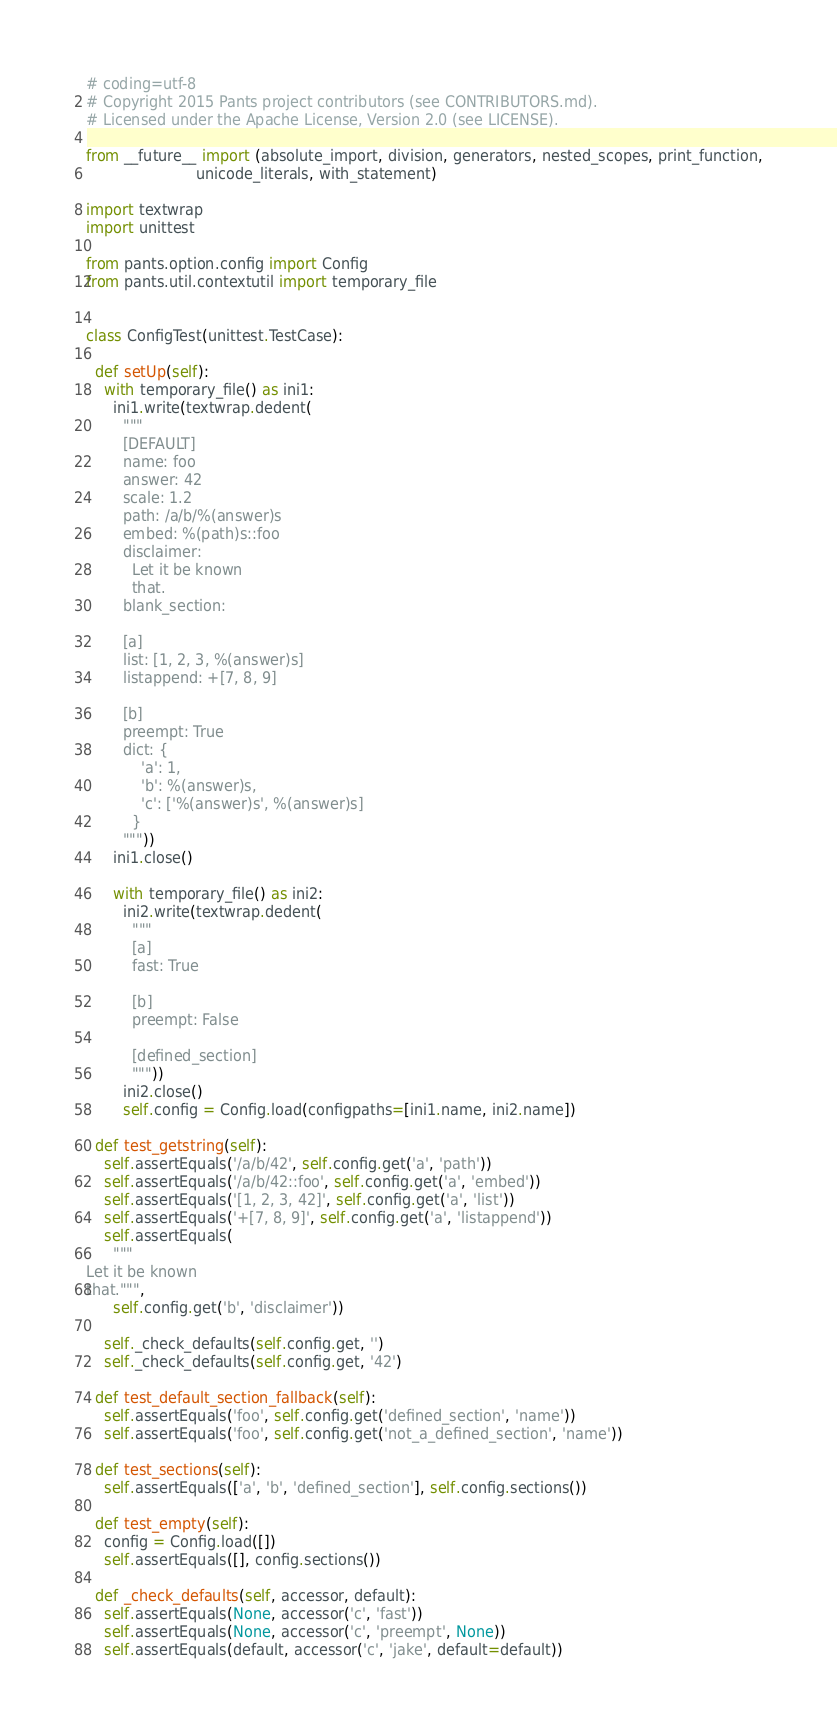<code> <loc_0><loc_0><loc_500><loc_500><_Python_># coding=utf-8
# Copyright 2015 Pants project contributors (see CONTRIBUTORS.md).
# Licensed under the Apache License, Version 2.0 (see LICENSE).

from __future__ import (absolute_import, division, generators, nested_scopes, print_function,
                        unicode_literals, with_statement)

import textwrap
import unittest

from pants.option.config import Config
from pants.util.contextutil import temporary_file


class ConfigTest(unittest.TestCase):

  def setUp(self):
    with temporary_file() as ini1:
      ini1.write(textwrap.dedent(
        """
        [DEFAULT]
        name: foo
        answer: 42
        scale: 1.2
        path: /a/b/%(answer)s
        embed: %(path)s::foo
        disclaimer:
          Let it be known
          that.
        blank_section:

        [a]
        list: [1, 2, 3, %(answer)s]
        listappend: +[7, 8, 9]

        [b]
        preempt: True
        dict: {
            'a': 1,
            'b': %(answer)s,
            'c': ['%(answer)s', %(answer)s]
          }
        """))
      ini1.close()

      with temporary_file() as ini2:
        ini2.write(textwrap.dedent(
          """
          [a]
          fast: True

          [b]
          preempt: False

          [defined_section]
          """))
        ini2.close()
        self.config = Config.load(configpaths=[ini1.name, ini2.name])

  def test_getstring(self):
    self.assertEquals('/a/b/42', self.config.get('a', 'path'))
    self.assertEquals('/a/b/42::foo', self.config.get('a', 'embed'))
    self.assertEquals('[1, 2, 3, 42]', self.config.get('a', 'list'))
    self.assertEquals('+[7, 8, 9]', self.config.get('a', 'listappend'))
    self.assertEquals(
      """
Let it be known
that.""",
      self.config.get('b', 'disclaimer'))

    self._check_defaults(self.config.get, '')
    self._check_defaults(self.config.get, '42')

  def test_default_section_fallback(self):
    self.assertEquals('foo', self.config.get('defined_section', 'name'))
    self.assertEquals('foo', self.config.get('not_a_defined_section', 'name'))

  def test_sections(self):
    self.assertEquals(['a', 'b', 'defined_section'], self.config.sections())

  def test_empty(self):
    config = Config.load([])
    self.assertEquals([], config.sections())

  def _check_defaults(self, accessor, default):
    self.assertEquals(None, accessor('c', 'fast'))
    self.assertEquals(None, accessor('c', 'preempt', None))
    self.assertEquals(default, accessor('c', 'jake', default=default))
</code> 